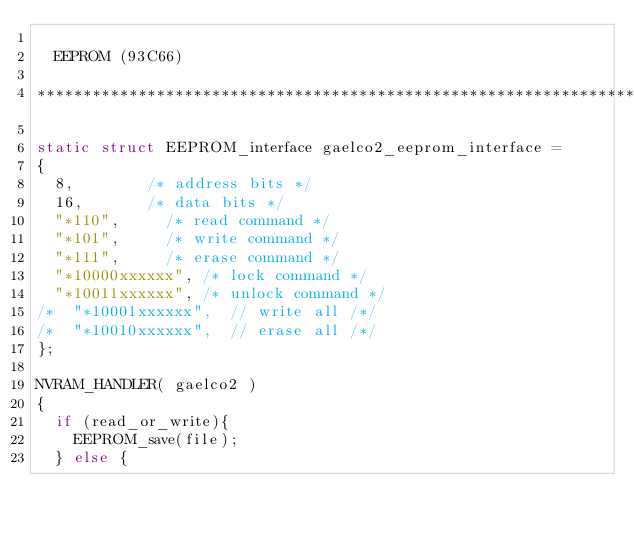<code> <loc_0><loc_0><loc_500><loc_500><_C_>
	EEPROM (93C66)

***************************************************************************/

static struct EEPROM_interface gaelco2_eeprom_interface =
{
	8,				/* address bits */
	16,				/* data bits */
	"*110",			/* read command */
	"*101",			/* write command */
	"*111",			/* erase command */
	"*10000xxxxxx",	/* lock command */
	"*10011xxxxxx", /* unlock command */
/*	"*10001xxxxxx",  // write all /*/
/*	"*10010xxxxxx",  // erase all /*/
};

NVRAM_HANDLER( gaelco2 )
{
	if (read_or_write){
		EEPROM_save(file);
	} else {</code> 